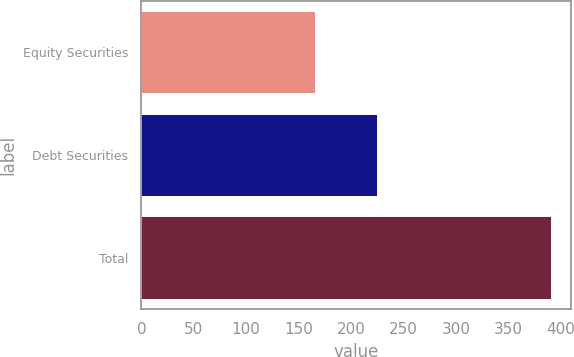Convert chart to OTSL. <chart><loc_0><loc_0><loc_500><loc_500><bar_chart><fcel>Equity Securities<fcel>Debt Securities<fcel>Total<nl><fcel>165.6<fcel>224.9<fcel>390.5<nl></chart> 